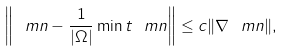<formula> <loc_0><loc_0><loc_500><loc_500>\left \| \ m n - \frac { 1 } { | \Omega | } \min t \ m n \right \| \leq c \| \nabla \ m n \| ,</formula> 